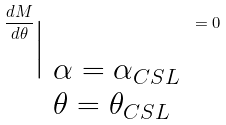<formula> <loc_0><loc_0><loc_500><loc_500>\frac { d M } { d \theta } _ { { \Big | } _ { \begin{array} { l l l l } \alpha = \alpha _ { C S L } \\ \theta = \theta _ { C S L } \end{array} } } = 0</formula> 